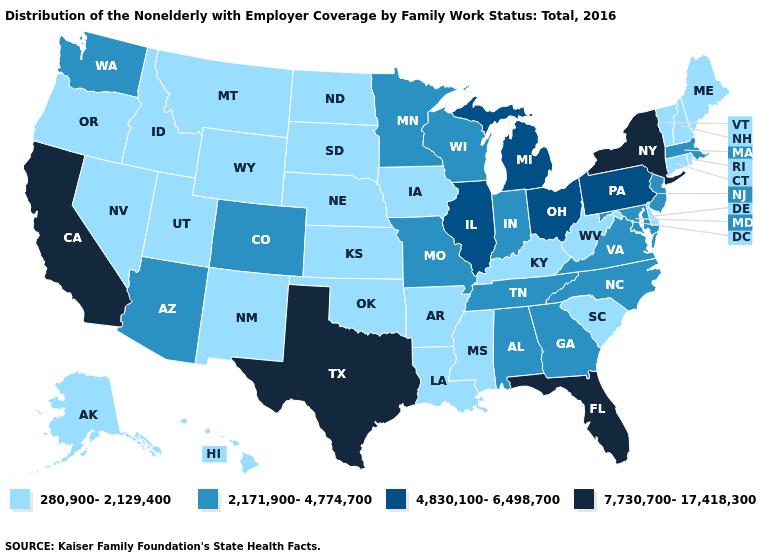Does Utah have the lowest value in the USA?
Quick response, please. Yes. Name the states that have a value in the range 280,900-2,129,400?
Be succinct. Alaska, Arkansas, Connecticut, Delaware, Hawaii, Idaho, Iowa, Kansas, Kentucky, Louisiana, Maine, Mississippi, Montana, Nebraska, Nevada, New Hampshire, New Mexico, North Dakota, Oklahoma, Oregon, Rhode Island, South Carolina, South Dakota, Utah, Vermont, West Virginia, Wyoming. What is the value of Oregon?
Give a very brief answer. 280,900-2,129,400. What is the value of New Mexico?
Answer briefly. 280,900-2,129,400. Which states have the highest value in the USA?
Keep it brief. California, Florida, New York, Texas. Name the states that have a value in the range 7,730,700-17,418,300?
Be succinct. California, Florida, New York, Texas. What is the value of Connecticut?
Keep it brief. 280,900-2,129,400. What is the value of South Carolina?
Answer briefly. 280,900-2,129,400. Name the states that have a value in the range 4,830,100-6,498,700?
Give a very brief answer. Illinois, Michigan, Ohio, Pennsylvania. Name the states that have a value in the range 2,171,900-4,774,700?
Short answer required. Alabama, Arizona, Colorado, Georgia, Indiana, Maryland, Massachusetts, Minnesota, Missouri, New Jersey, North Carolina, Tennessee, Virginia, Washington, Wisconsin. What is the lowest value in states that border South Carolina?
Short answer required. 2,171,900-4,774,700. Name the states that have a value in the range 2,171,900-4,774,700?
Write a very short answer. Alabama, Arizona, Colorado, Georgia, Indiana, Maryland, Massachusetts, Minnesota, Missouri, New Jersey, North Carolina, Tennessee, Virginia, Washington, Wisconsin. What is the lowest value in the USA?
Quick response, please. 280,900-2,129,400. Name the states that have a value in the range 280,900-2,129,400?
Give a very brief answer. Alaska, Arkansas, Connecticut, Delaware, Hawaii, Idaho, Iowa, Kansas, Kentucky, Louisiana, Maine, Mississippi, Montana, Nebraska, Nevada, New Hampshire, New Mexico, North Dakota, Oklahoma, Oregon, Rhode Island, South Carolina, South Dakota, Utah, Vermont, West Virginia, Wyoming. Does Massachusetts have the lowest value in the USA?
Short answer required. No. 